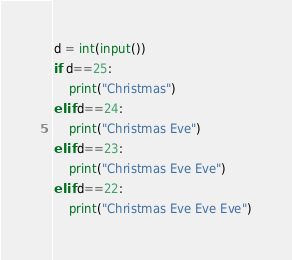<code> <loc_0><loc_0><loc_500><loc_500><_Python_>d = int(input())
if d==25:
    print("Christmas")
elif d==24:
    print("Christmas Eve")
elif d==23:
    print("Christmas Eve Eve")
elif d==22:
    print("Christmas Eve Eve Eve")</code> 